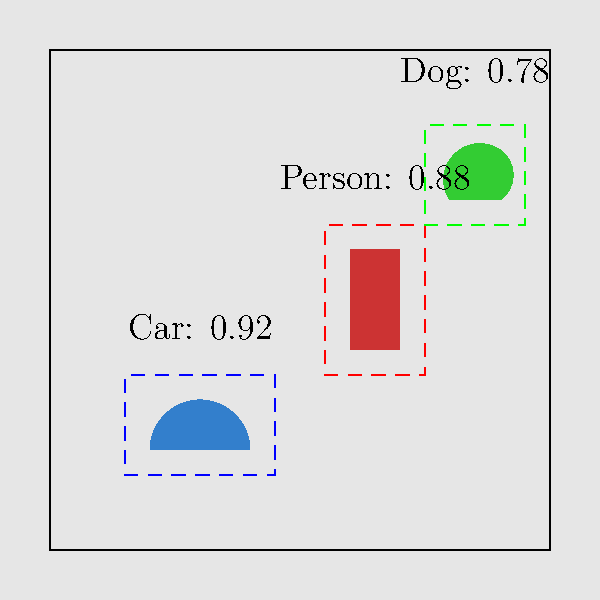In the YOLO object detection results shown above, what is the Intersection over Union (IoU) threshold typically used to determine if a detection is considered a true positive? To answer this question, let's break down the concept of Intersection over Union (IoU) and its role in YOLO object detection:

1. IoU is a metric used to measure the overlap between the predicted bounding box and the ground truth bounding box.

2. It is calculated as:
   $$ IoU = \frac{\text{Area of Intersection}}{\text{Area of Union}} $$

3. The IoU threshold is used to determine if a detection is considered a true positive or a false positive.

4. In YOLO (You Only Look Once) algorithm, the typical IoU threshold used is 0.5 or 50%.

5. This means:
   - If IoU ≥ 0.5, the detection is considered a true positive.
   - If IoU < 0.5, the detection is considered a false positive.

6. The choice of 0.5 as a threshold is a balance between precision and recall:
   - A higher threshold would increase precision but decrease recall.
   - A lower threshold would increase recall but decrease precision.

7. In some applications, this threshold might be adjusted based on specific requirements, but 0.5 is the most commonly used value in YOLO implementations.

8. The image shows bounding boxes for detected objects (car, person, dog) with their confidence scores, which is typical output from a YOLO model. The IoU threshold would be applied to these detections to determine their validity.
Answer: 0.5 (or 50%) 